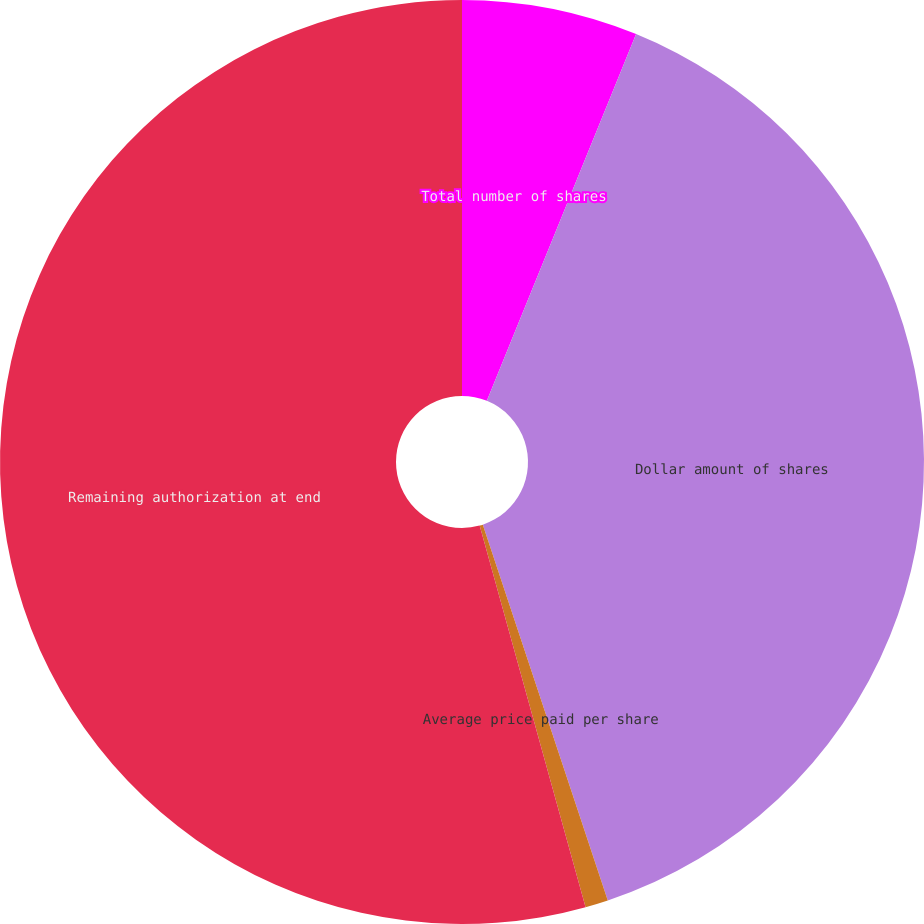<chart> <loc_0><loc_0><loc_500><loc_500><pie_chart><fcel>Total number of shares<fcel>Dollar amount of shares<fcel>Average price paid per share<fcel>Remaining authorization at end<nl><fcel>6.15%<fcel>38.74%<fcel>0.8%<fcel>54.31%<nl></chart> 